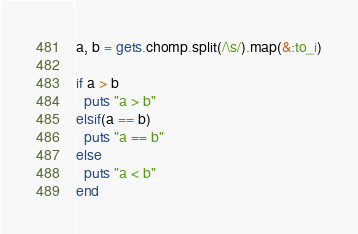<code> <loc_0><loc_0><loc_500><loc_500><_Ruby_>a, b = gets.chomp.split(/\s/).map(&:to_i)

if a > b
  puts "a > b"
elsif(a == b)
  puts "a == b"
else
  puts "a < b"
end</code> 